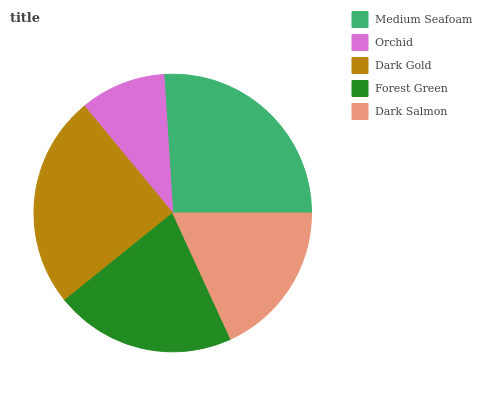Is Orchid the minimum?
Answer yes or no. Yes. Is Medium Seafoam the maximum?
Answer yes or no. Yes. Is Dark Gold the minimum?
Answer yes or no. No. Is Dark Gold the maximum?
Answer yes or no. No. Is Dark Gold greater than Orchid?
Answer yes or no. Yes. Is Orchid less than Dark Gold?
Answer yes or no. Yes. Is Orchid greater than Dark Gold?
Answer yes or no. No. Is Dark Gold less than Orchid?
Answer yes or no. No. Is Forest Green the high median?
Answer yes or no. Yes. Is Forest Green the low median?
Answer yes or no. Yes. Is Orchid the high median?
Answer yes or no. No. Is Medium Seafoam the low median?
Answer yes or no. No. 